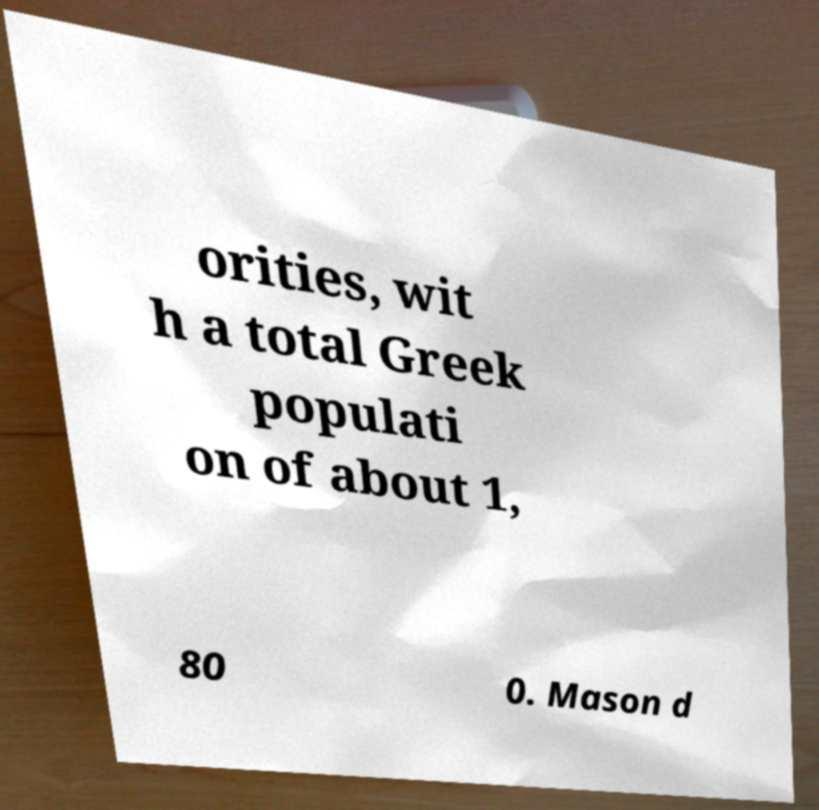Could you assist in decoding the text presented in this image and type it out clearly? orities, wit h a total Greek populati on of about 1, 80 0. Mason d 